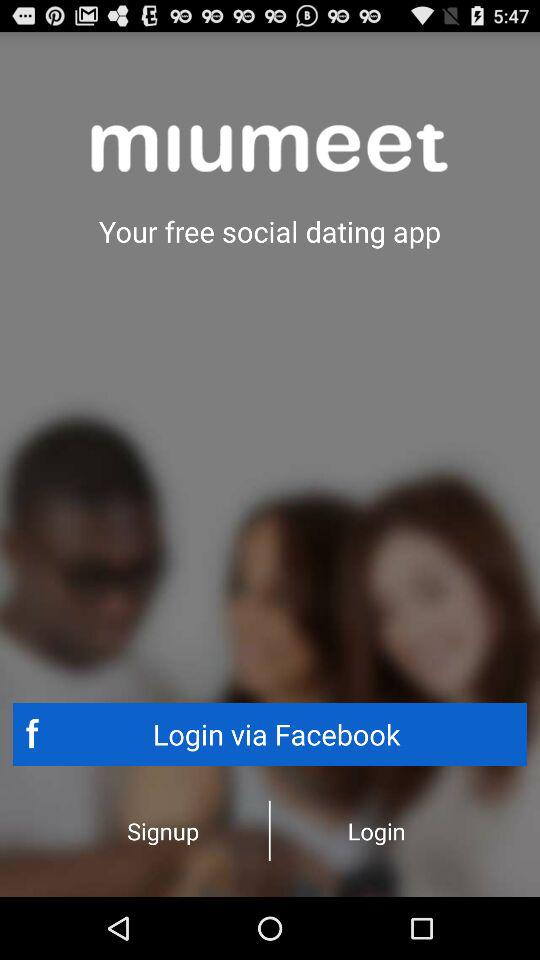What is the name of the application? The name of the application is "miumeet". 